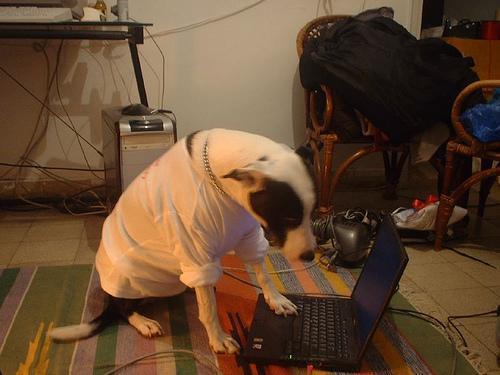How many dogs are there?
Give a very brief answer. 1. How many chairs are visible?
Give a very brief answer. 2. 